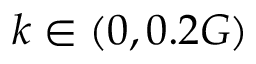Convert formula to latex. <formula><loc_0><loc_0><loc_500><loc_500>k \in ( 0 , 0 . 2 G )</formula> 